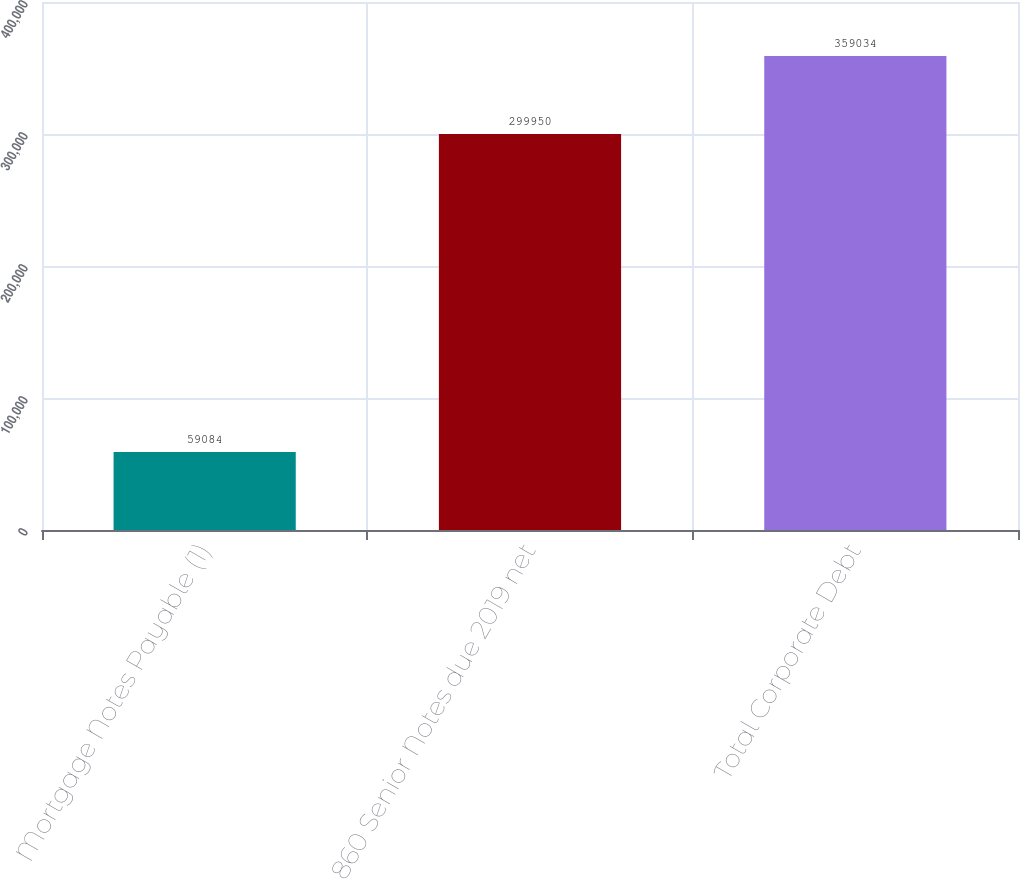<chart> <loc_0><loc_0><loc_500><loc_500><bar_chart><fcel>Mortgage Notes Payable (1)<fcel>860 Senior Notes due 2019 net<fcel>Total Corporate Debt<nl><fcel>59084<fcel>299950<fcel>359034<nl></chart> 